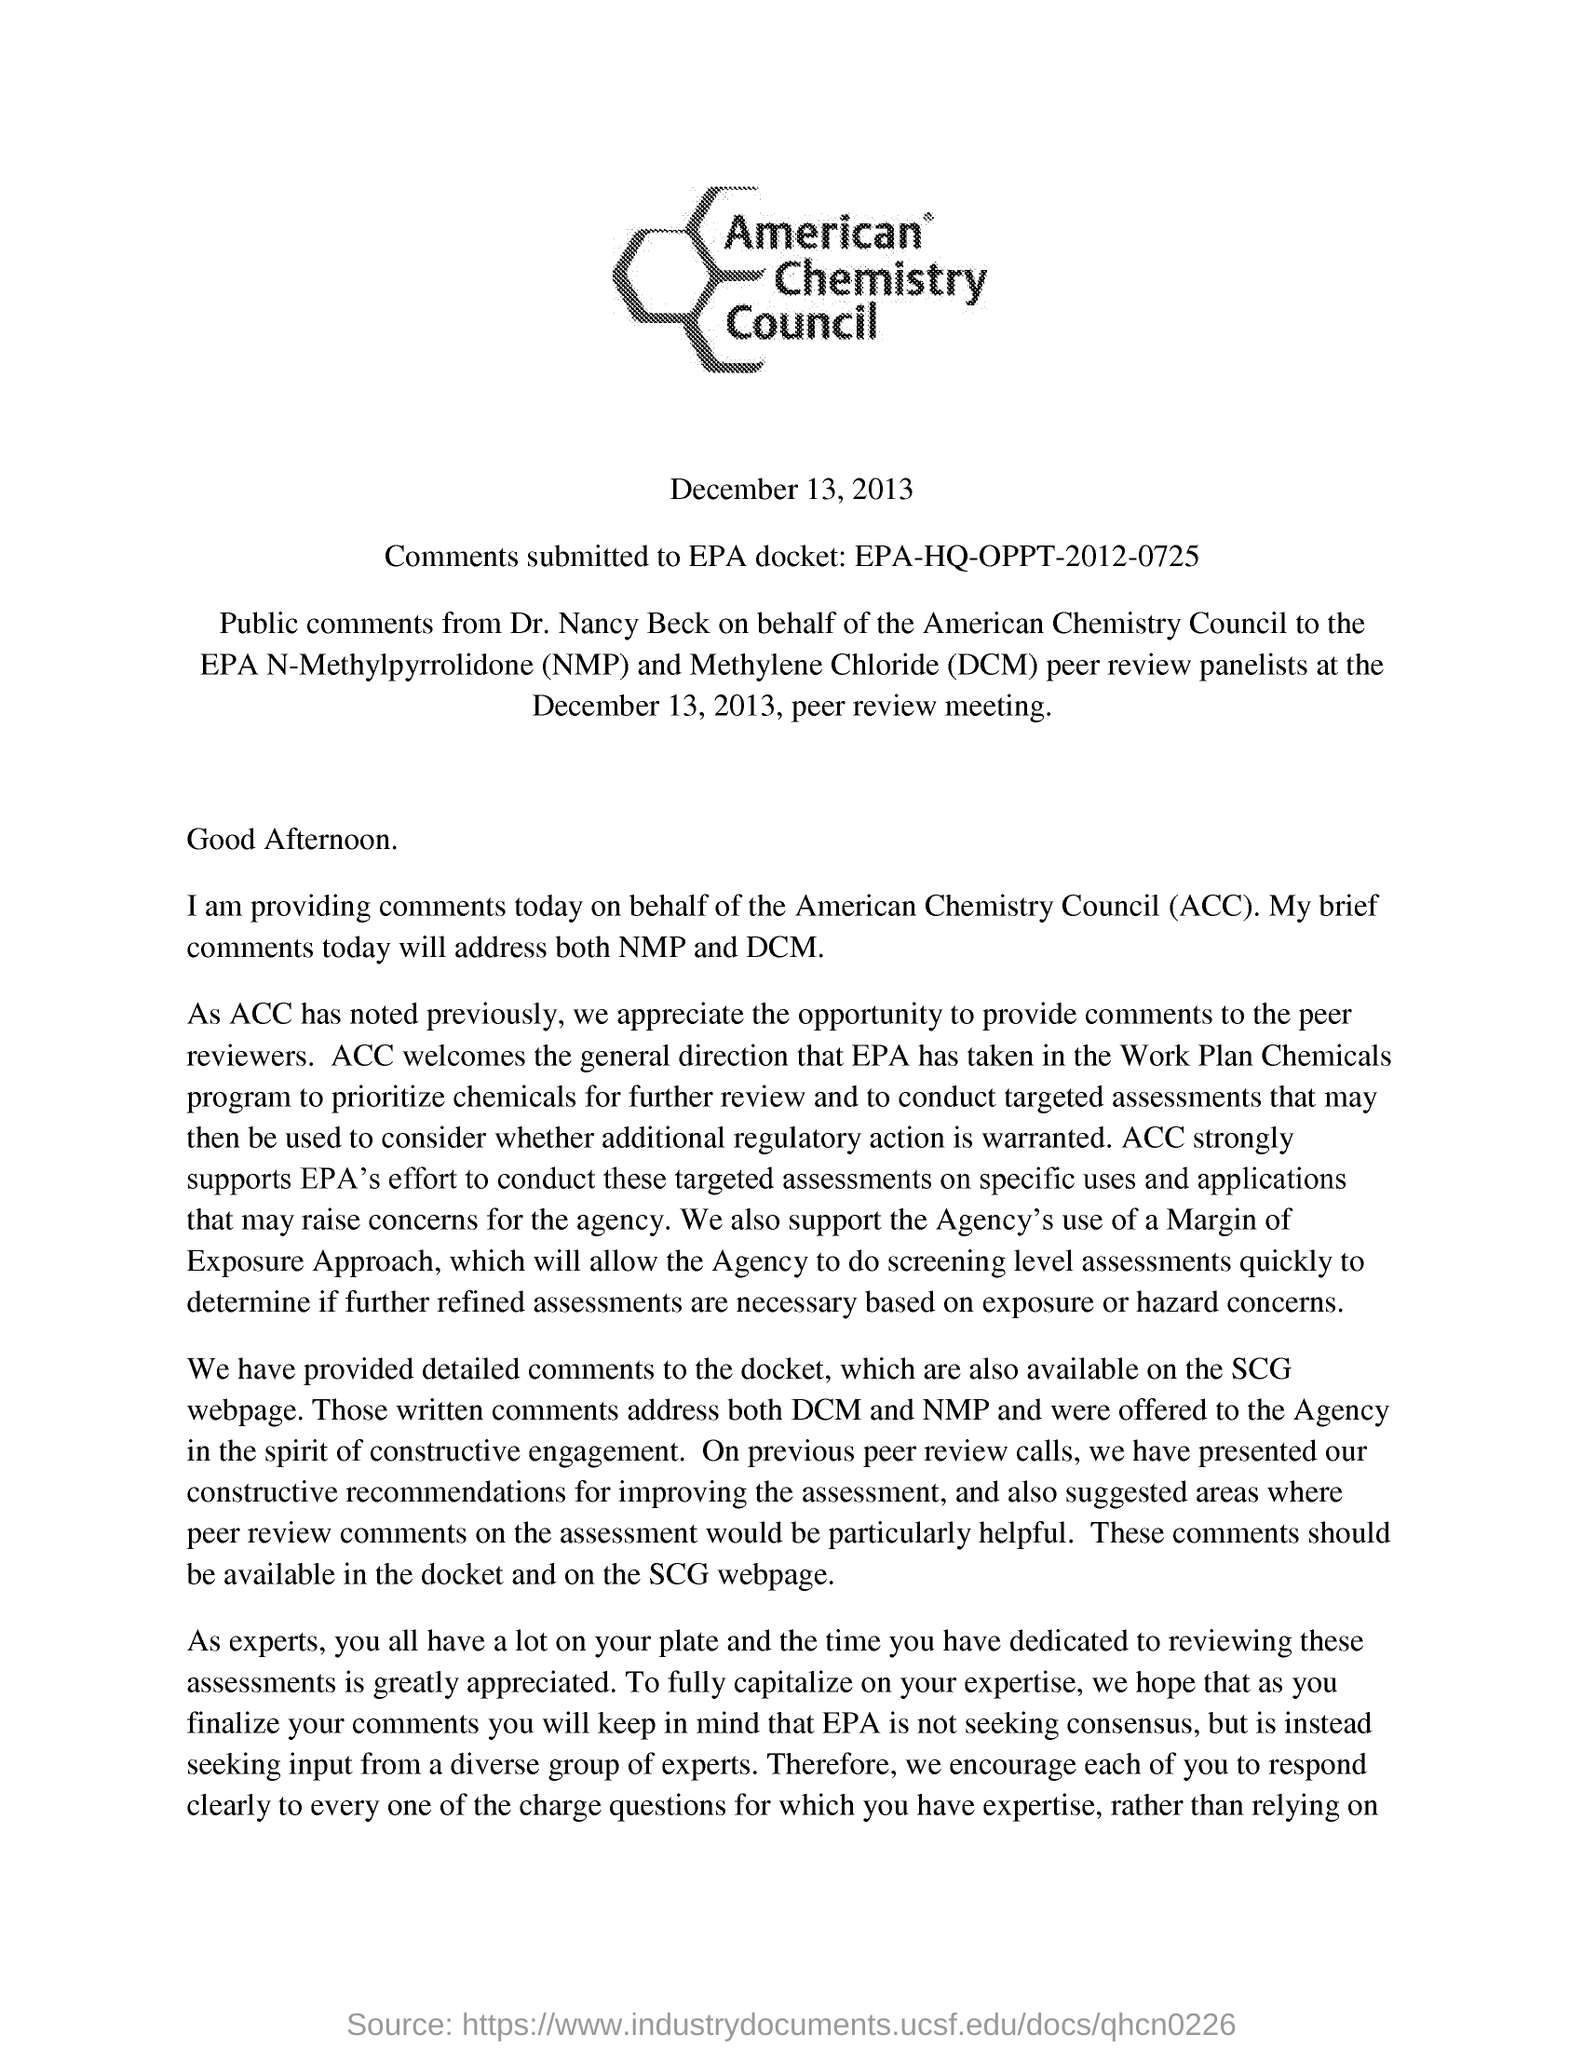Draw attention to some important aspects in this diagram. On behalf of the American Chemistry Council, Dr. Nancy Beck submitted the public comments. Public comments are submitted by Dr. Nancy Beck. The date of the peer review meeting is December 13, 2013. The submitted comments for the EPA docket ID EPA-HQ-OPPT-2012-0725 are: "What is the comments subbmitted EPA docket ID? EPA-HQ-OPPT-2012-0725.. The comments are also available on the SCG webpage. 